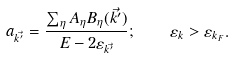<formula> <loc_0><loc_0><loc_500><loc_500>a _ { \vec { k ^ { \prime } } } = \frac { \sum _ { \eta } A _ { \eta } B _ { \eta } ( \vec { k ^ { \prime } } ) } { E - 2 \varepsilon _ { \vec { k ^ { \prime } } } } ; \quad \varepsilon _ { k } > \varepsilon _ { k _ { F } } .</formula> 